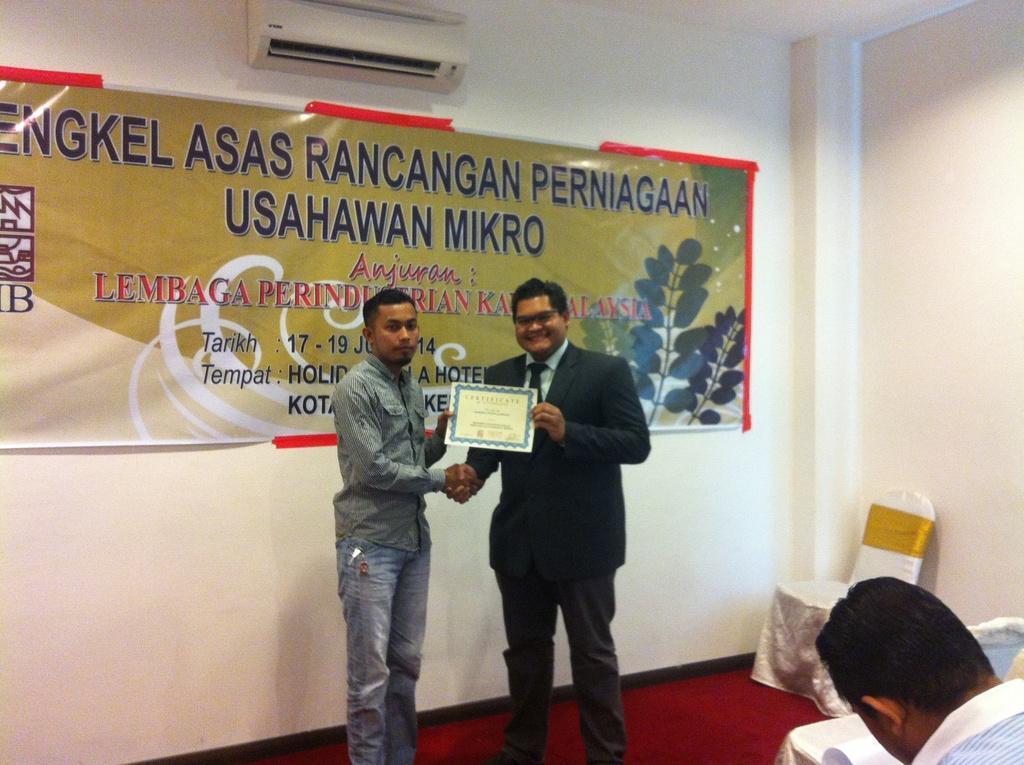How would you summarize this image in a sentence or two? In the picture I can see two men are standing and holding a certificate in hands. In the background I can see a banner and an air conditioner attached to the wall. On the banner I can see something written on it. Here I can see a person and chairs on the floor. 